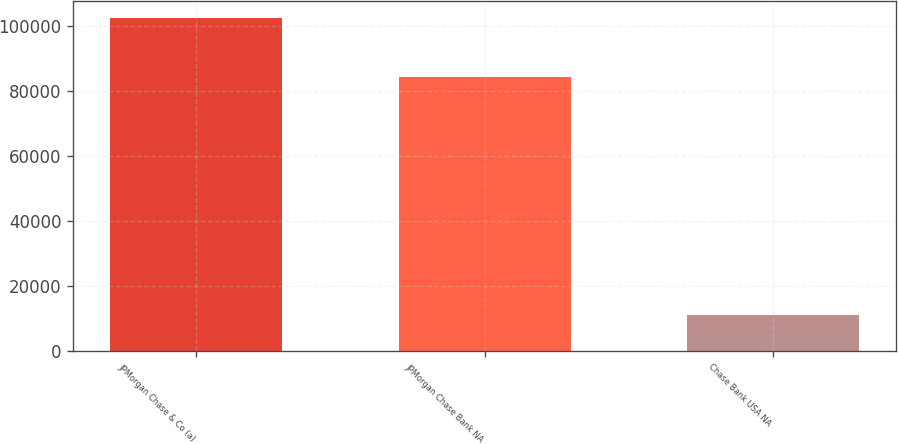<chart> <loc_0><loc_0><loc_500><loc_500><bar_chart><fcel>JPMorgan Chase & Co (a)<fcel>JPMorgan Chase Bank NA<fcel>Chase Bank USA NA<nl><fcel>102437<fcel>84227<fcel>10941<nl></chart> 